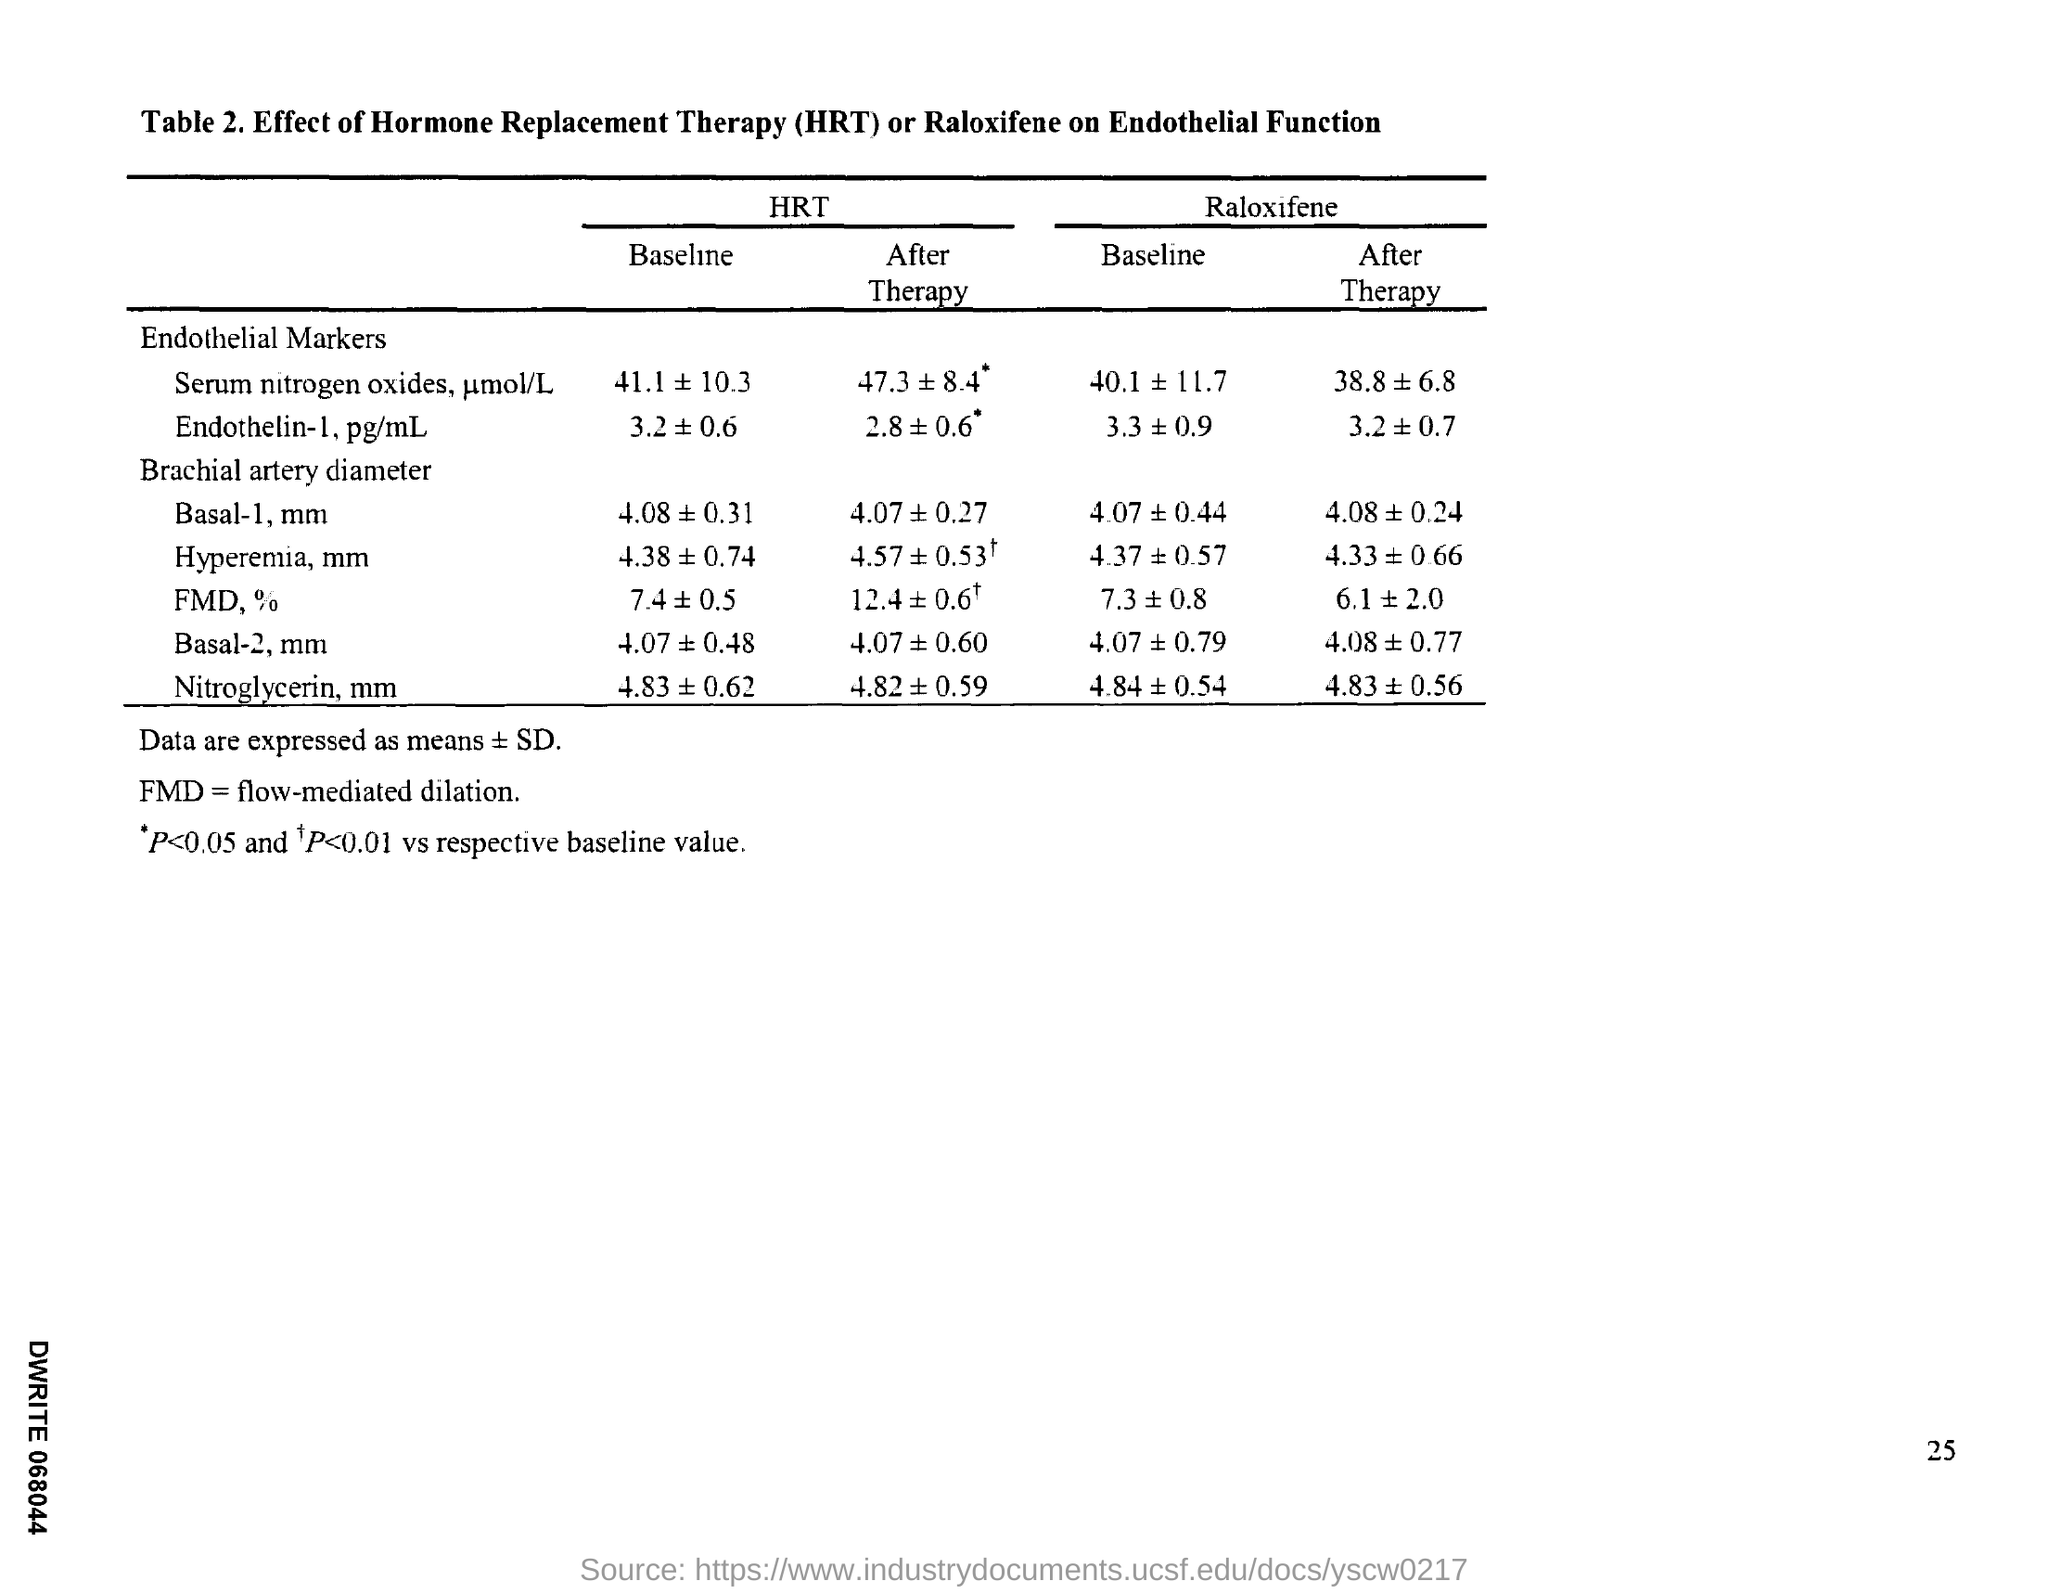Full form of FMD?
Provide a succinct answer. Flow-mediated dilation. Full form of HRT?
Provide a short and direct response. Hormone replacement therapy. 